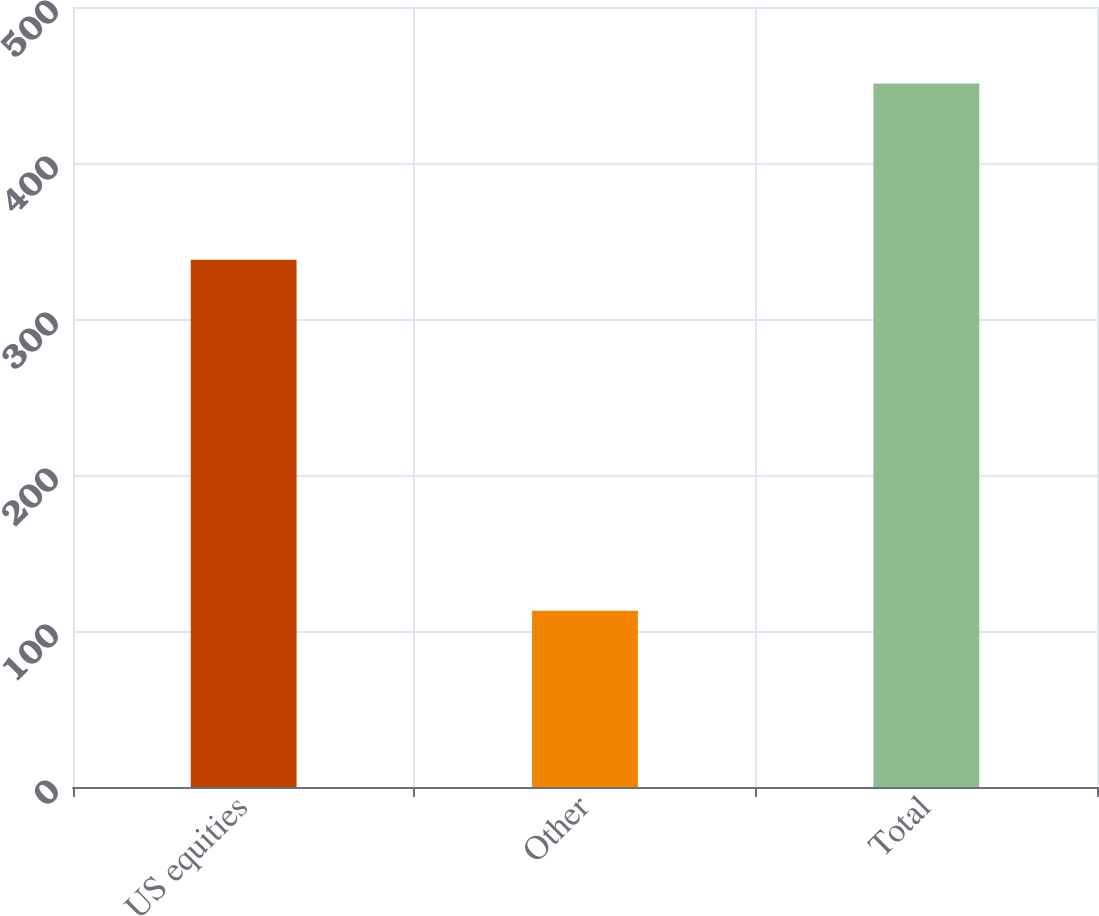Convert chart. <chart><loc_0><loc_0><loc_500><loc_500><bar_chart><fcel>US equities<fcel>Other<fcel>Total<nl><fcel>338<fcel>113<fcel>451<nl></chart> 